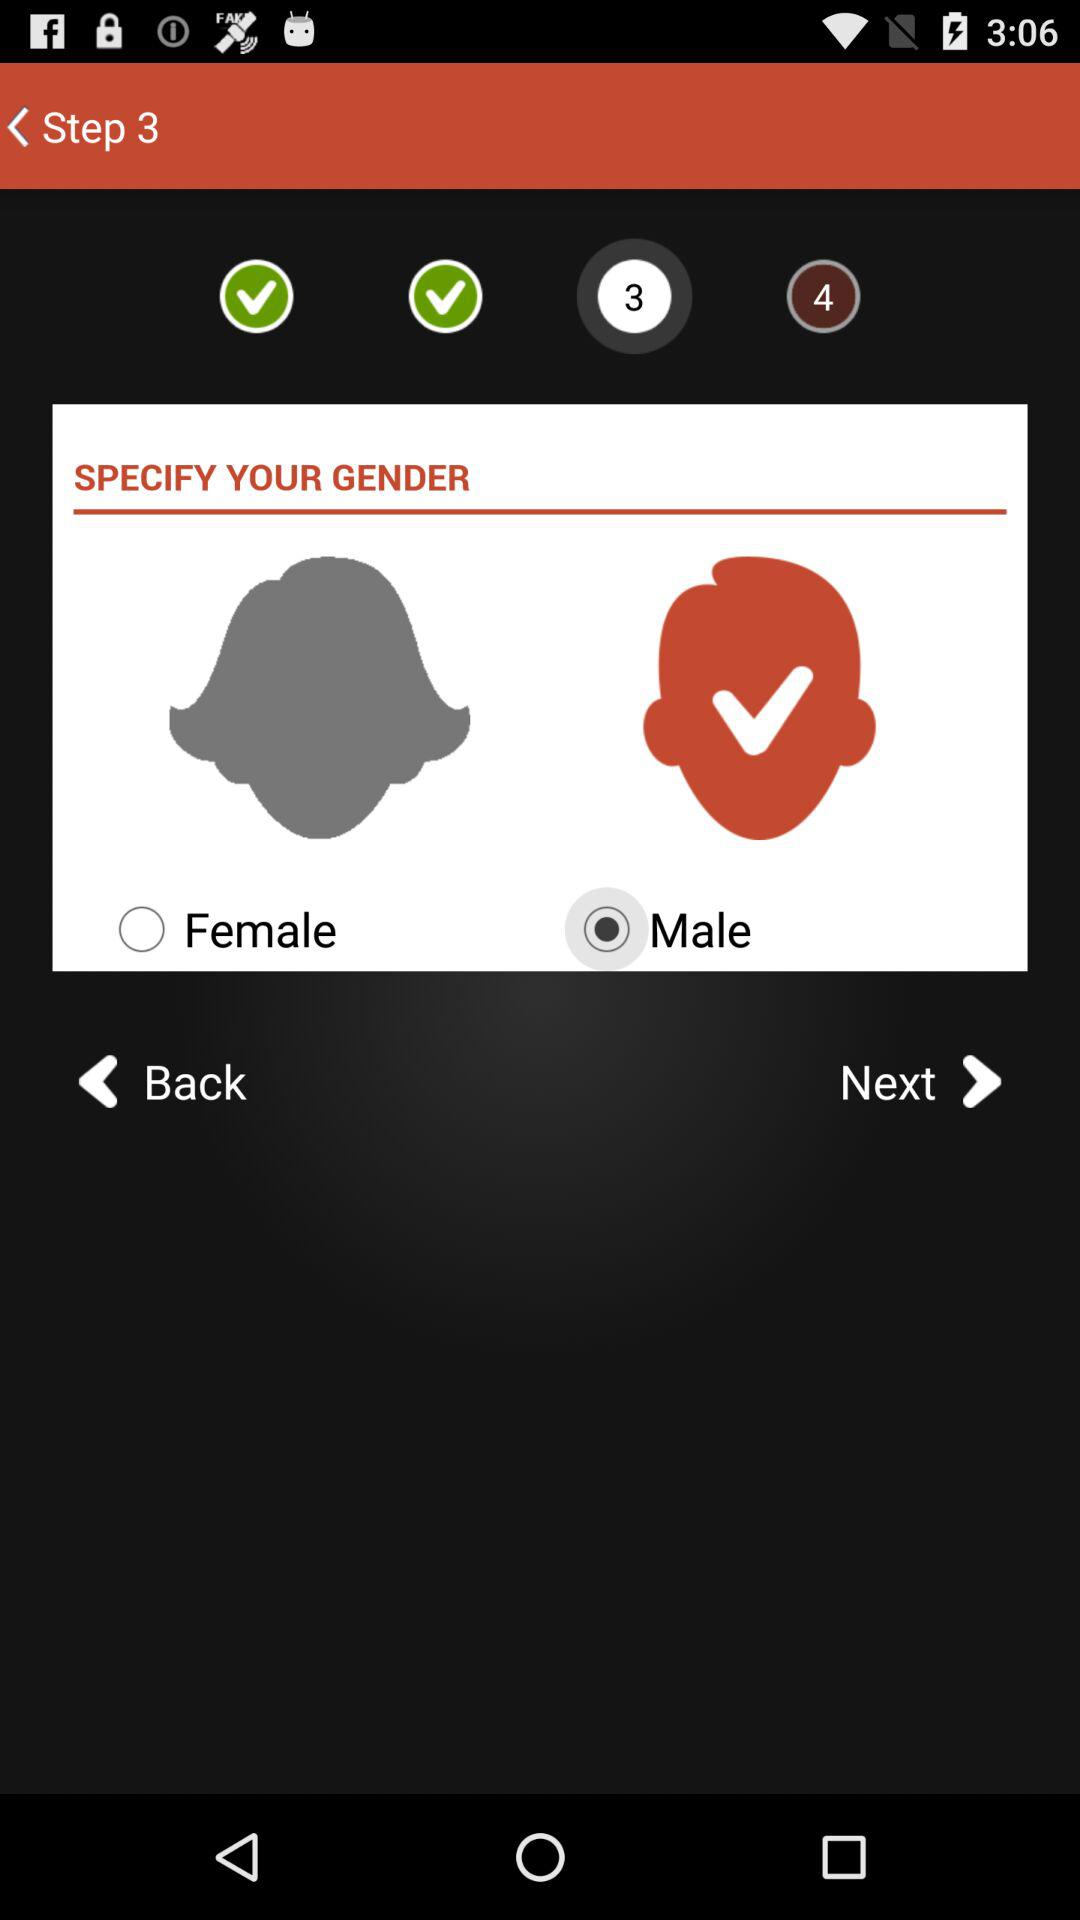Which gender is selected? The selected gender is "Male". 